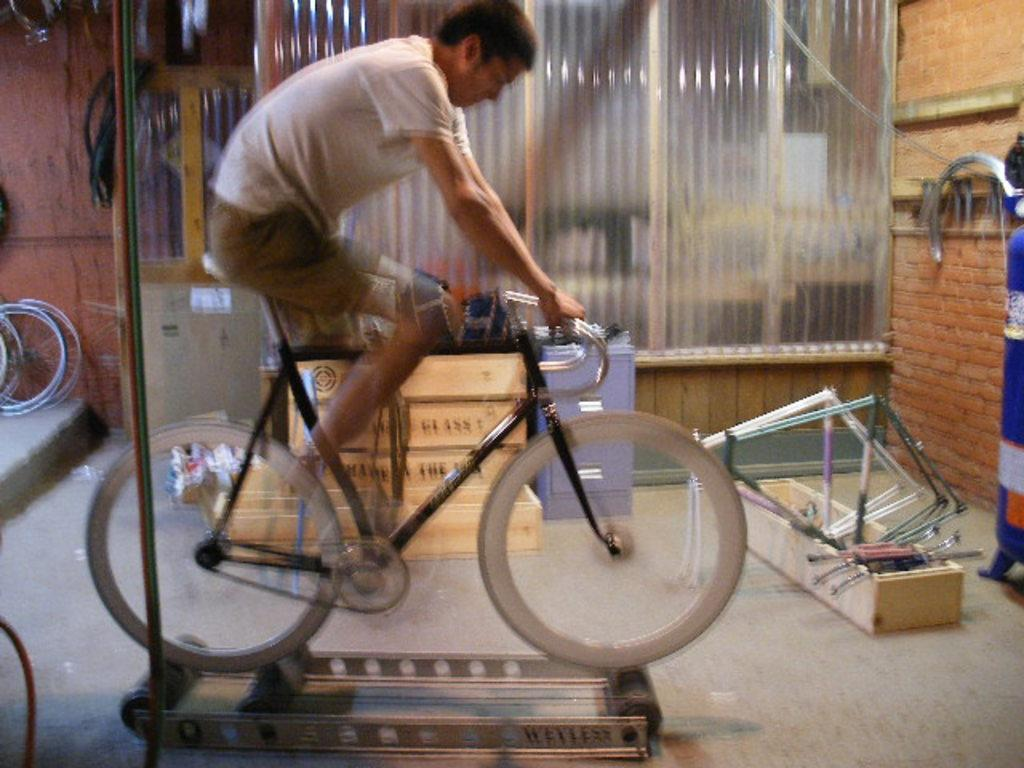What is the man in the image doing? The man is riding a bicycle in the image. Can you see any other bicycles in the image? Yes, there are bicycles in the distance. What is on the floor in the image? There are objects on the floor in the image. What type of brush is the duck using to talk in the image? There is no duck or brush present in the image, and no one is talking. 